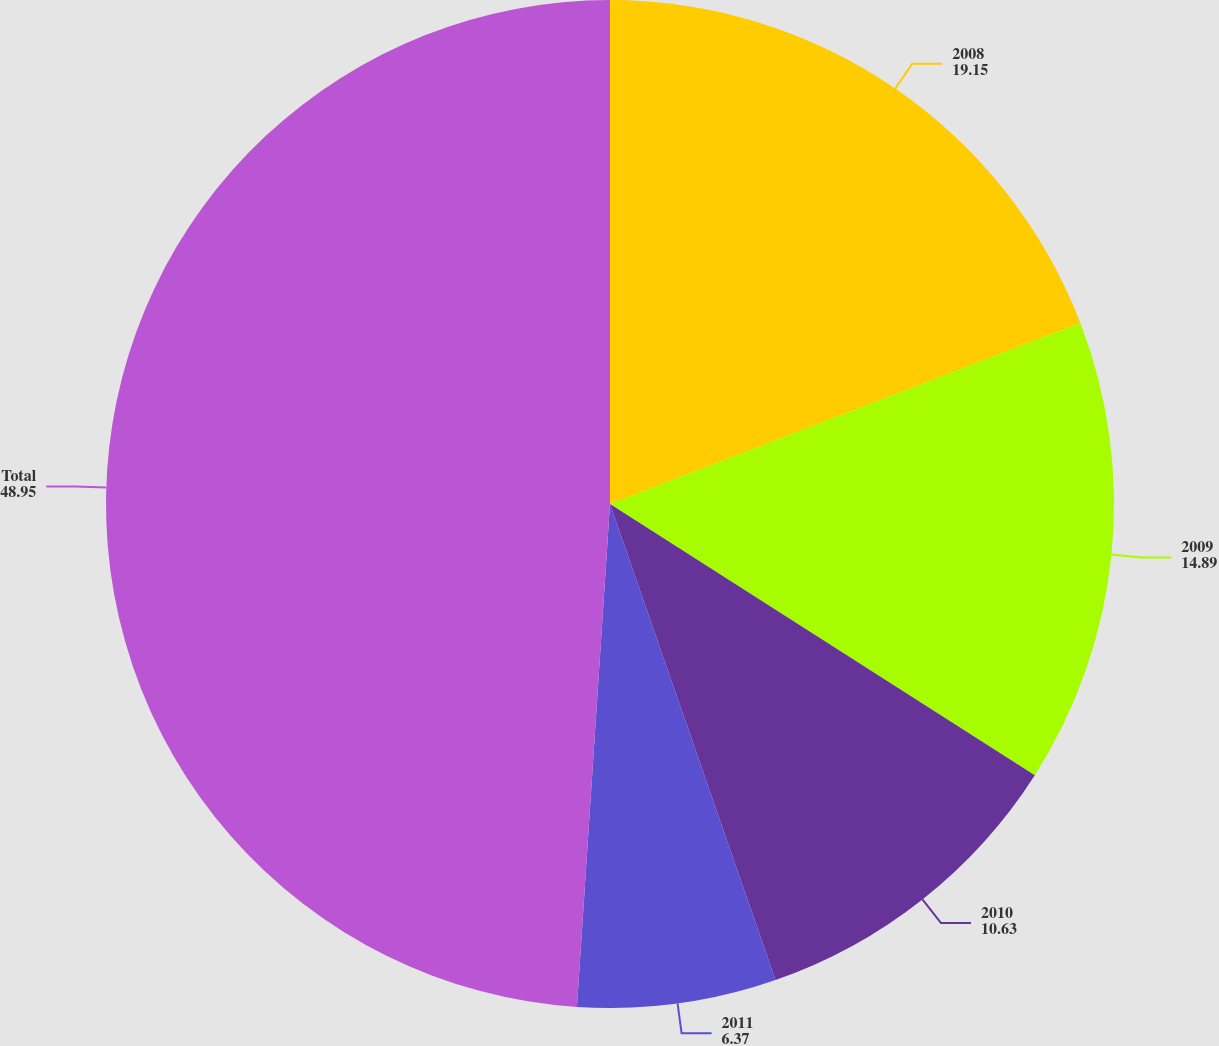Convert chart to OTSL. <chart><loc_0><loc_0><loc_500><loc_500><pie_chart><fcel>2008<fcel>2009<fcel>2010<fcel>2011<fcel>Total<nl><fcel>19.15%<fcel>14.89%<fcel>10.63%<fcel>6.37%<fcel>48.95%<nl></chart> 